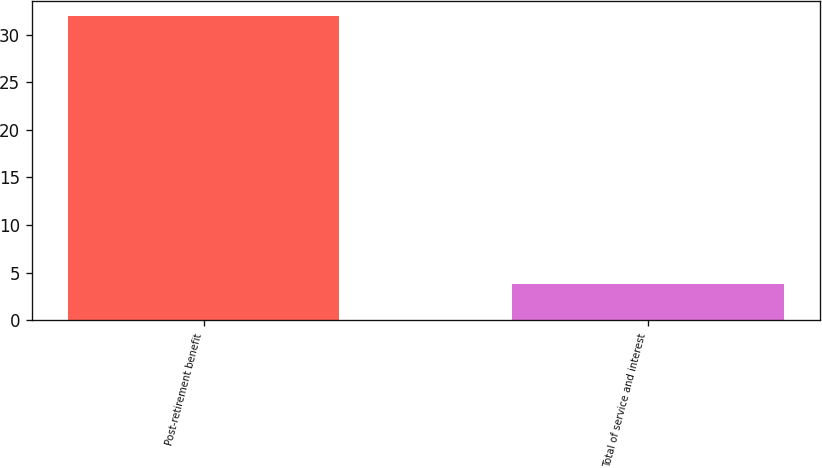Convert chart to OTSL. <chart><loc_0><loc_0><loc_500><loc_500><bar_chart><fcel>Post-retirement benefit<fcel>Total of service and interest<nl><fcel>31.9<fcel>3.8<nl></chart> 